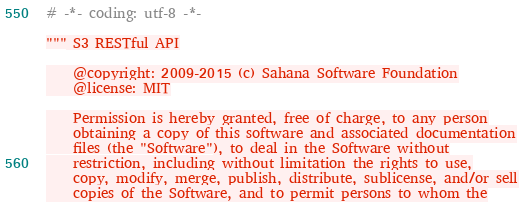<code> <loc_0><loc_0><loc_500><loc_500><_Python_># -*- coding: utf-8 -*-

""" S3 RESTful API

    @copyright: 2009-2015 (c) Sahana Software Foundation
    @license: MIT

    Permission is hereby granted, free of charge, to any person
    obtaining a copy of this software and associated documentation
    files (the "Software"), to deal in the Software without
    restriction, including without limitation the rights to use,
    copy, modify, merge, publish, distribute, sublicense, and/or sell
    copies of the Software, and to permit persons to whom the</code> 